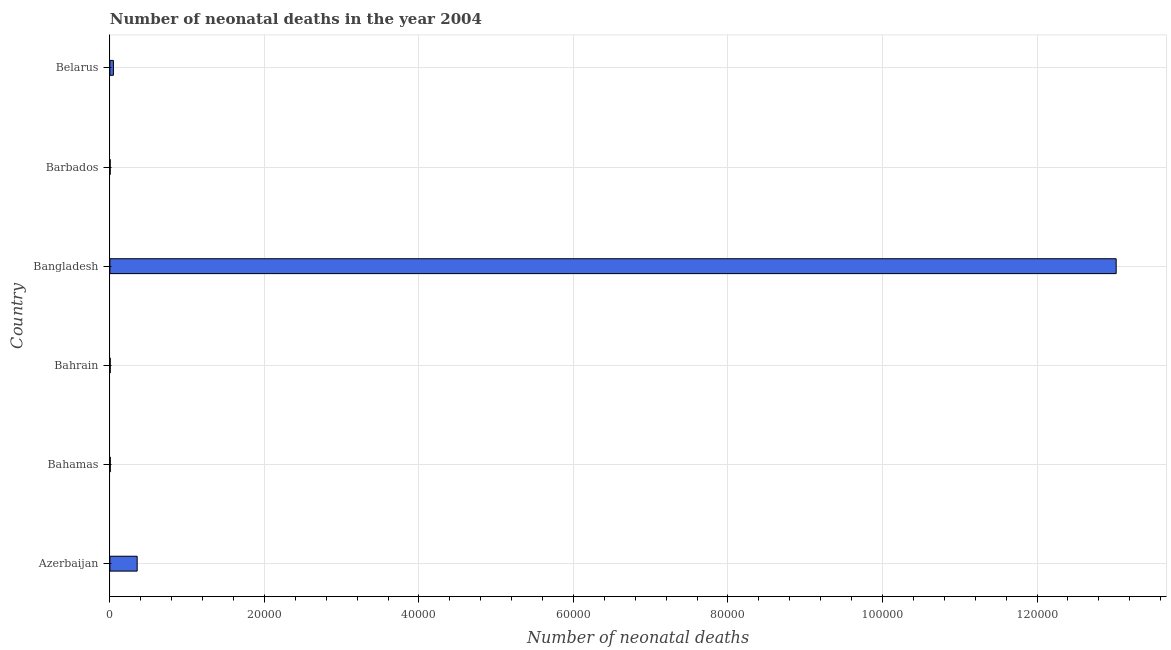Does the graph contain any zero values?
Your answer should be compact. No. What is the title of the graph?
Provide a succinct answer. Number of neonatal deaths in the year 2004. What is the label or title of the X-axis?
Provide a succinct answer. Number of neonatal deaths. What is the number of neonatal deaths in Barbados?
Your response must be concise. 36. Across all countries, what is the maximum number of neonatal deaths?
Your answer should be compact. 1.30e+05. In which country was the number of neonatal deaths minimum?
Keep it short and to the point. Barbados. What is the sum of the number of neonatal deaths?
Make the answer very short. 1.34e+05. What is the difference between the number of neonatal deaths in Bahrain and Barbados?
Keep it short and to the point. 3. What is the average number of neonatal deaths per country?
Offer a very short reply. 2.24e+04. What is the median number of neonatal deaths?
Offer a terse response. 252.5. In how many countries, is the number of neonatal deaths greater than 4000 ?
Keep it short and to the point. 1. What is the ratio of the number of neonatal deaths in Azerbaijan to that in Bangladesh?
Offer a very short reply. 0.03. Is the number of neonatal deaths in Azerbaijan less than that in Bahamas?
Make the answer very short. No. What is the difference between the highest and the second highest number of neonatal deaths?
Keep it short and to the point. 1.27e+05. What is the difference between the highest and the lowest number of neonatal deaths?
Your response must be concise. 1.30e+05. How many bars are there?
Keep it short and to the point. 6. What is the difference between two consecutive major ticks on the X-axis?
Your response must be concise. 2.00e+04. What is the Number of neonatal deaths of Azerbaijan?
Provide a short and direct response. 3531. What is the Number of neonatal deaths in Bahrain?
Give a very brief answer. 39. What is the Number of neonatal deaths of Bangladesh?
Provide a succinct answer. 1.30e+05. What is the Number of neonatal deaths in Barbados?
Keep it short and to the point. 36. What is the Number of neonatal deaths of Belarus?
Offer a terse response. 457. What is the difference between the Number of neonatal deaths in Azerbaijan and Bahamas?
Give a very brief answer. 3483. What is the difference between the Number of neonatal deaths in Azerbaijan and Bahrain?
Give a very brief answer. 3492. What is the difference between the Number of neonatal deaths in Azerbaijan and Bangladesh?
Keep it short and to the point. -1.27e+05. What is the difference between the Number of neonatal deaths in Azerbaijan and Barbados?
Make the answer very short. 3495. What is the difference between the Number of neonatal deaths in Azerbaijan and Belarus?
Provide a succinct answer. 3074. What is the difference between the Number of neonatal deaths in Bahamas and Bangladesh?
Make the answer very short. -1.30e+05. What is the difference between the Number of neonatal deaths in Bahamas and Barbados?
Keep it short and to the point. 12. What is the difference between the Number of neonatal deaths in Bahamas and Belarus?
Your answer should be very brief. -409. What is the difference between the Number of neonatal deaths in Bahrain and Bangladesh?
Give a very brief answer. -1.30e+05. What is the difference between the Number of neonatal deaths in Bahrain and Belarus?
Offer a very short reply. -418. What is the difference between the Number of neonatal deaths in Bangladesh and Barbados?
Keep it short and to the point. 1.30e+05. What is the difference between the Number of neonatal deaths in Bangladesh and Belarus?
Keep it short and to the point. 1.30e+05. What is the difference between the Number of neonatal deaths in Barbados and Belarus?
Provide a short and direct response. -421. What is the ratio of the Number of neonatal deaths in Azerbaijan to that in Bahamas?
Keep it short and to the point. 73.56. What is the ratio of the Number of neonatal deaths in Azerbaijan to that in Bahrain?
Offer a very short reply. 90.54. What is the ratio of the Number of neonatal deaths in Azerbaijan to that in Bangladesh?
Your answer should be very brief. 0.03. What is the ratio of the Number of neonatal deaths in Azerbaijan to that in Barbados?
Offer a terse response. 98.08. What is the ratio of the Number of neonatal deaths in Azerbaijan to that in Belarus?
Offer a very short reply. 7.73. What is the ratio of the Number of neonatal deaths in Bahamas to that in Bahrain?
Keep it short and to the point. 1.23. What is the ratio of the Number of neonatal deaths in Bahamas to that in Barbados?
Provide a short and direct response. 1.33. What is the ratio of the Number of neonatal deaths in Bahamas to that in Belarus?
Keep it short and to the point. 0.1. What is the ratio of the Number of neonatal deaths in Bahrain to that in Bangladesh?
Give a very brief answer. 0. What is the ratio of the Number of neonatal deaths in Bahrain to that in Barbados?
Make the answer very short. 1.08. What is the ratio of the Number of neonatal deaths in Bahrain to that in Belarus?
Ensure brevity in your answer.  0.09. What is the ratio of the Number of neonatal deaths in Bangladesh to that in Barbados?
Ensure brevity in your answer.  3617.92. What is the ratio of the Number of neonatal deaths in Bangladesh to that in Belarus?
Offer a very short reply. 285. What is the ratio of the Number of neonatal deaths in Barbados to that in Belarus?
Provide a short and direct response. 0.08. 